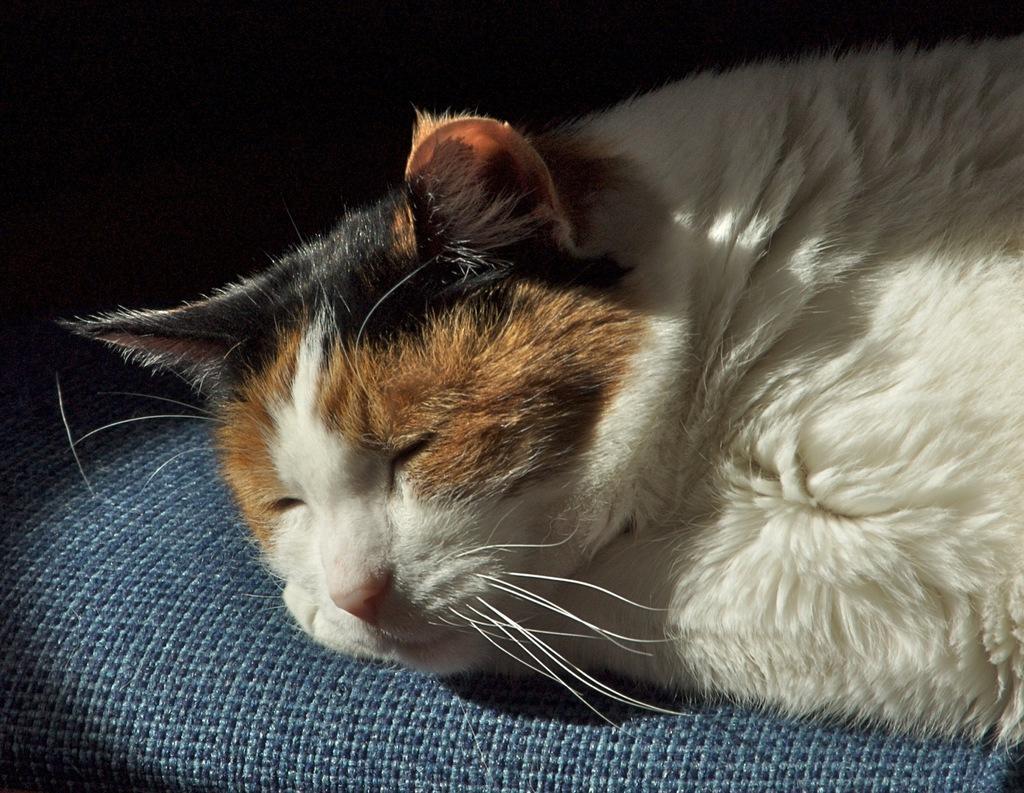Describe this image in one or two sentences. In the picture I can a cat is lying on a surface. The background of the image is dark. 